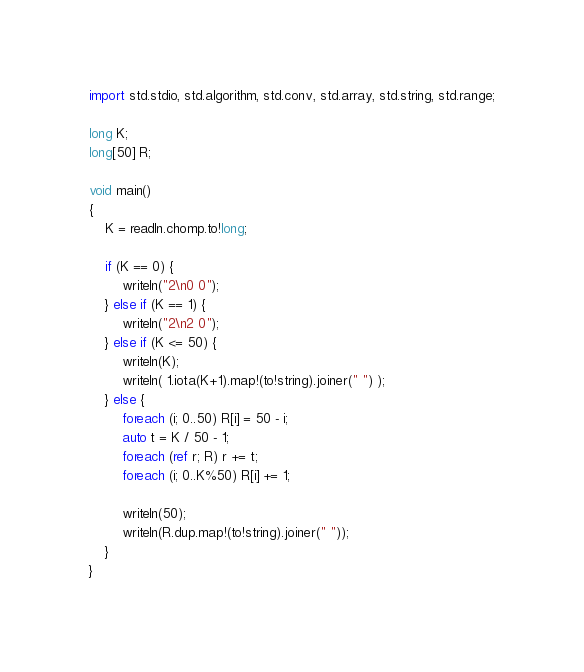Convert code to text. <code><loc_0><loc_0><loc_500><loc_500><_D_>import std.stdio, std.algorithm, std.conv, std.array, std.string, std.range;

long K;
long[50] R;

void main()
{
    K = readln.chomp.to!long;

    if (K == 0) {
        writeln("2\n0 0");
    } else if (K == 1) {
        writeln("2\n2 0");
    } else if (K <= 50) {
        writeln(K);
        writeln( 1.iota(K+1).map!(to!string).joiner(" ") );
    } else {
        foreach (i; 0..50) R[i] = 50 - i;
        auto t = K / 50 - 1;
        foreach (ref r; R) r += t;
        foreach (i; 0..K%50) R[i] += 1;

        writeln(50);
        writeln(R.dup.map!(to!string).joiner(" ")); 
    }
}</code> 